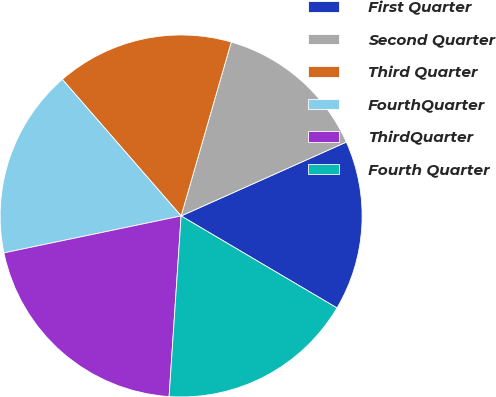Convert chart. <chart><loc_0><loc_0><loc_500><loc_500><pie_chart><fcel>First Quarter<fcel>Second Quarter<fcel>Third Quarter<fcel>FourthQuarter<fcel>ThirdQuarter<fcel>Fourth Quarter<nl><fcel>15.18%<fcel>13.84%<fcel>15.86%<fcel>16.88%<fcel>20.67%<fcel>17.57%<nl></chart> 